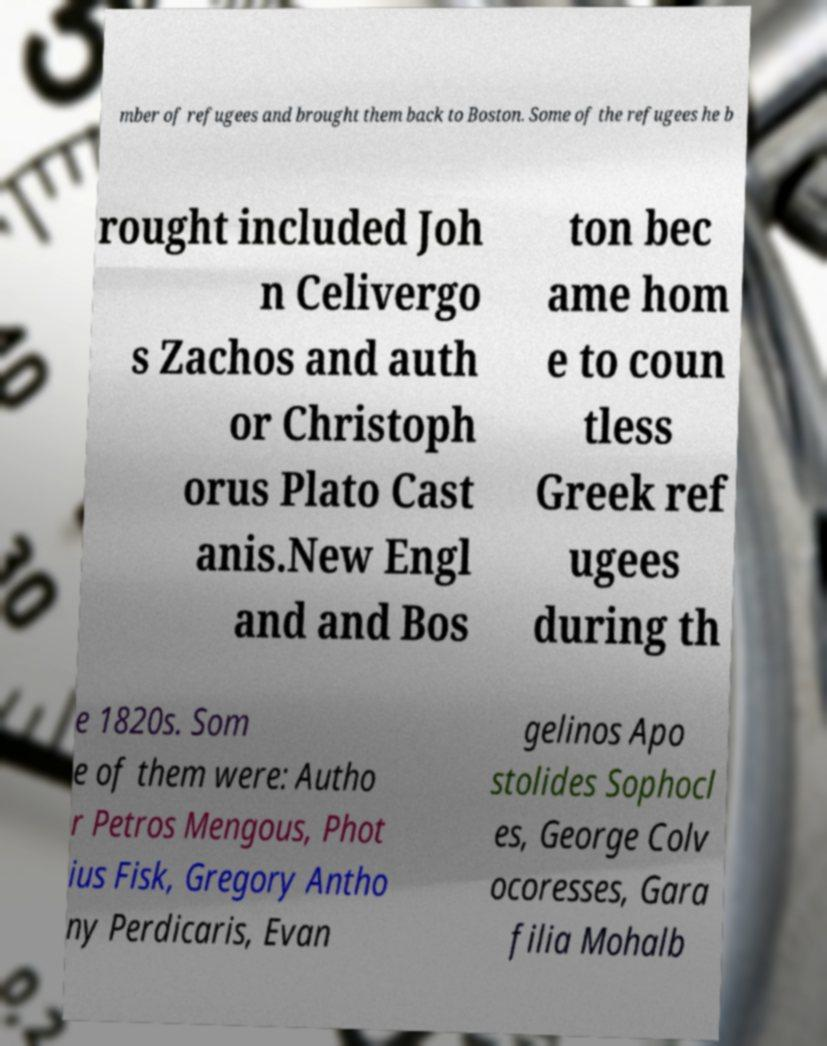Please read and relay the text visible in this image. What does it say? mber of refugees and brought them back to Boston. Some of the refugees he b rought included Joh n Celivergo s Zachos and auth or Christoph orus Plato Cast anis.New Engl and and Bos ton bec ame hom e to coun tless Greek ref ugees during th e 1820s. Som e of them were: Autho r Petros Mengous, Phot ius Fisk, Gregory Antho ny Perdicaris, Evan gelinos Apo stolides Sophocl es, George Colv ocoresses, Gara filia Mohalb 